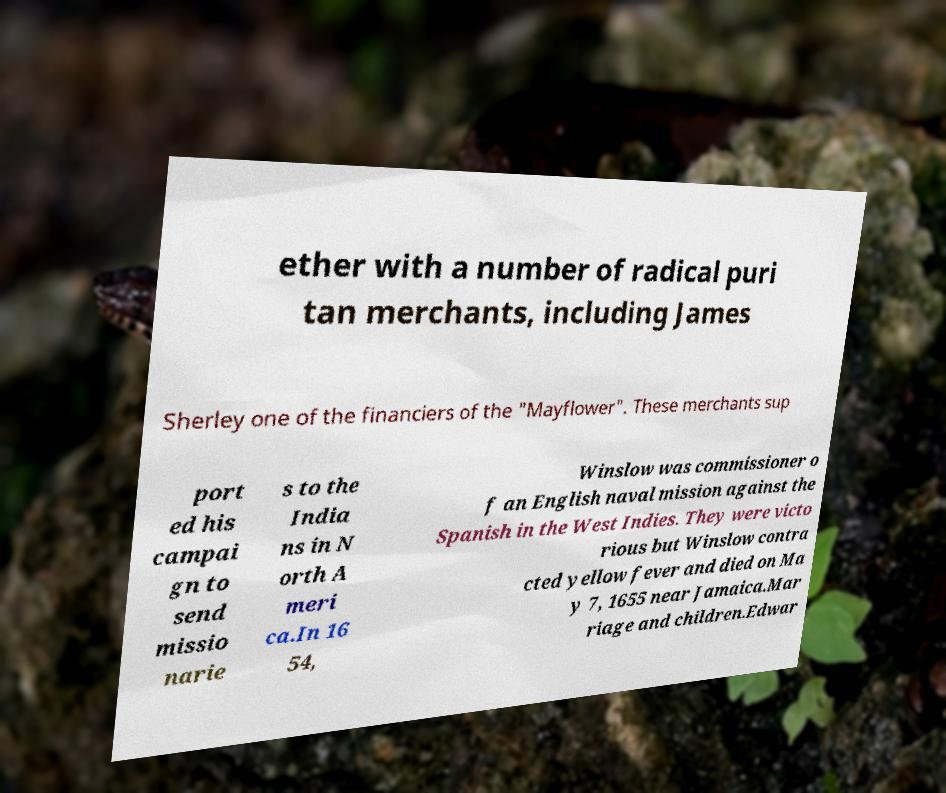There's text embedded in this image that I need extracted. Can you transcribe it verbatim? ether with a number of radical puri tan merchants, including James Sherley one of the financiers of the "Mayflower". These merchants sup port ed his campai gn to send missio narie s to the India ns in N orth A meri ca.In 16 54, Winslow was commissioner o f an English naval mission against the Spanish in the West Indies. They were victo rious but Winslow contra cted yellow fever and died on Ma y 7, 1655 near Jamaica.Mar riage and children.Edwar 